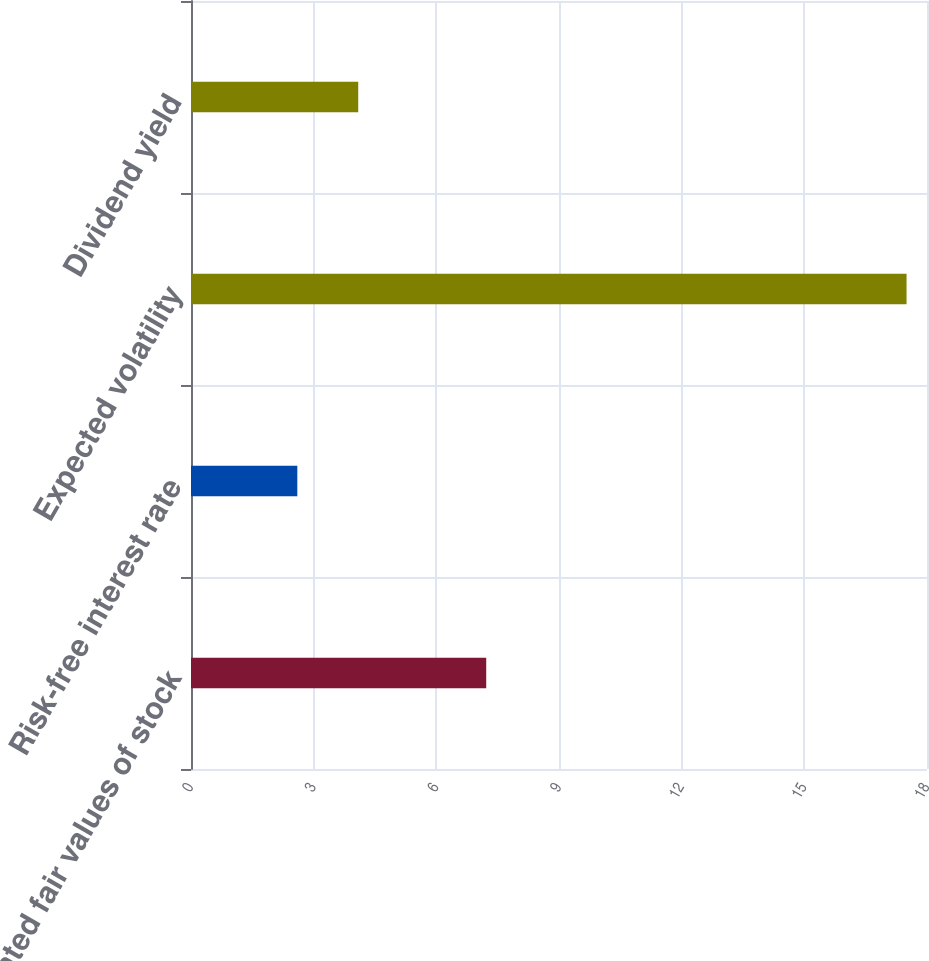<chart> <loc_0><loc_0><loc_500><loc_500><bar_chart><fcel>Estimated fair values of stock<fcel>Risk-free interest rate<fcel>Expected volatility<fcel>Dividend yield<nl><fcel>7.22<fcel>2.6<fcel>17.5<fcel>4.09<nl></chart> 